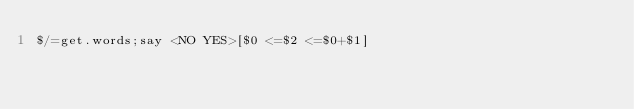<code> <loc_0><loc_0><loc_500><loc_500><_Perl_>$/=get.words;say <NO YES>[$0 <=$2 <=$0+$1]</code> 